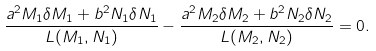<formula> <loc_0><loc_0><loc_500><loc_500>\frac { a ^ { 2 } M _ { 1 } \delta M _ { 1 } + b ^ { 2 } N _ { 1 } \delta N _ { 1 } } { L ( M _ { 1 } , N _ { 1 } ) } - \frac { a ^ { 2 } M _ { 2 } \delta M _ { 2 } + b ^ { 2 } N _ { 2 } \delta N _ { 2 } } { L ( M _ { 2 } , N _ { 2 } ) } = 0 .</formula> 